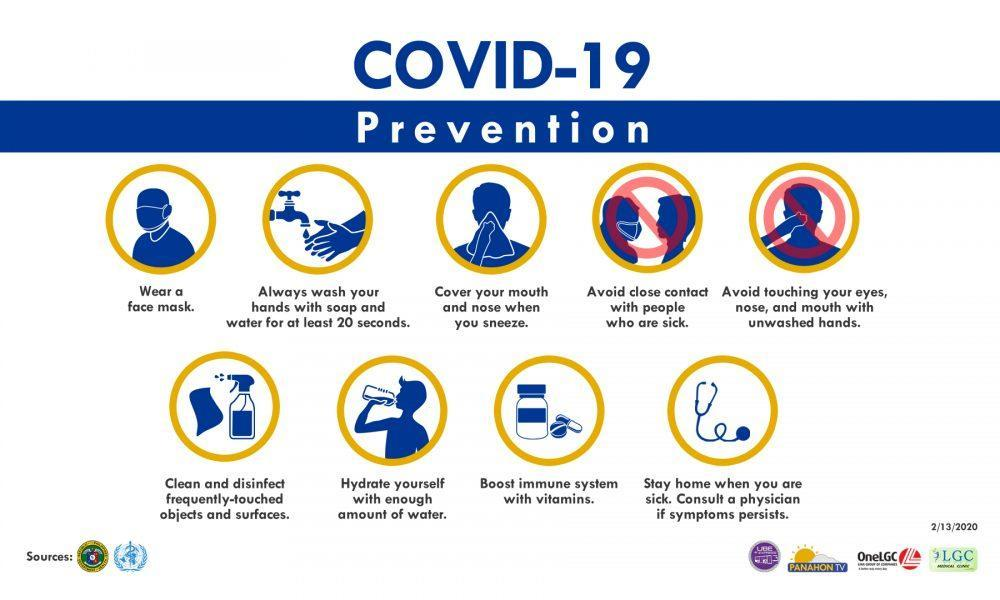How many preventive measures are in this infographic?
Answer the question with a short phrase. 9 What are the parts of the face? eyes, nose, mouth 